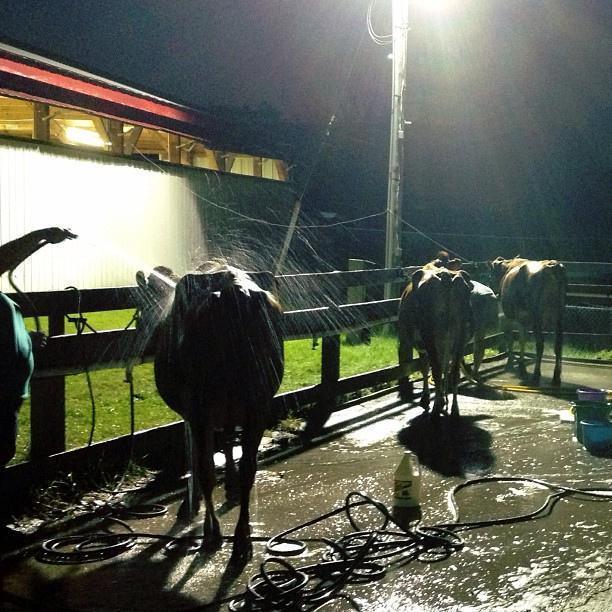What is happening in the photo?
Select the correct answer and articulate reasoning with the following format: 'Answer: answer
Rationale: rationale.'
Options: Thunderstorm, flooding, cow showering, raining. Answer: cow showering.
Rationale: There is a hose on the ground and everything is wet after being sprayed. 